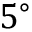Convert formula to latex. <formula><loc_0><loc_0><loc_500><loc_500>5 ^ { \circ }</formula> 